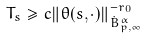Convert formula to latex. <formula><loc_0><loc_0><loc_500><loc_500>T _ { s } \geq c \| \theta ( s , \cdot ) \| _ { { \dot { B } ^ { \alpha } _ { p , \infty } } } ^ { - r _ { 0 } }</formula> 